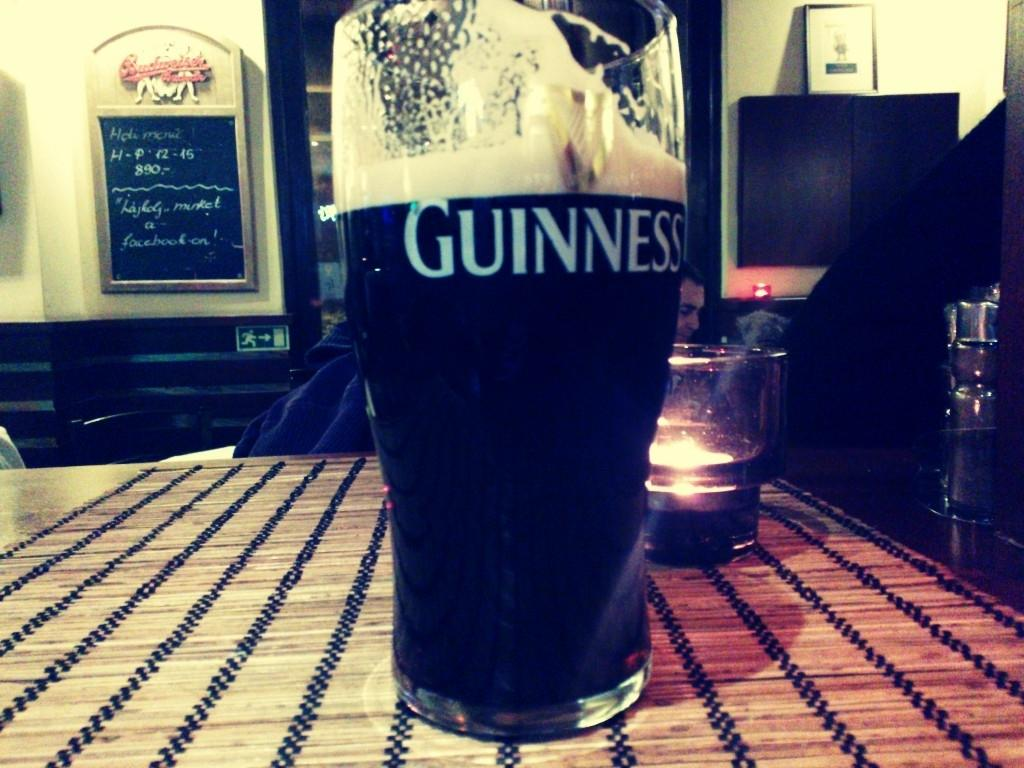<image>
Offer a succinct explanation of the picture presented. A glass of Guinness appears to have had a few sips taken out of it. 